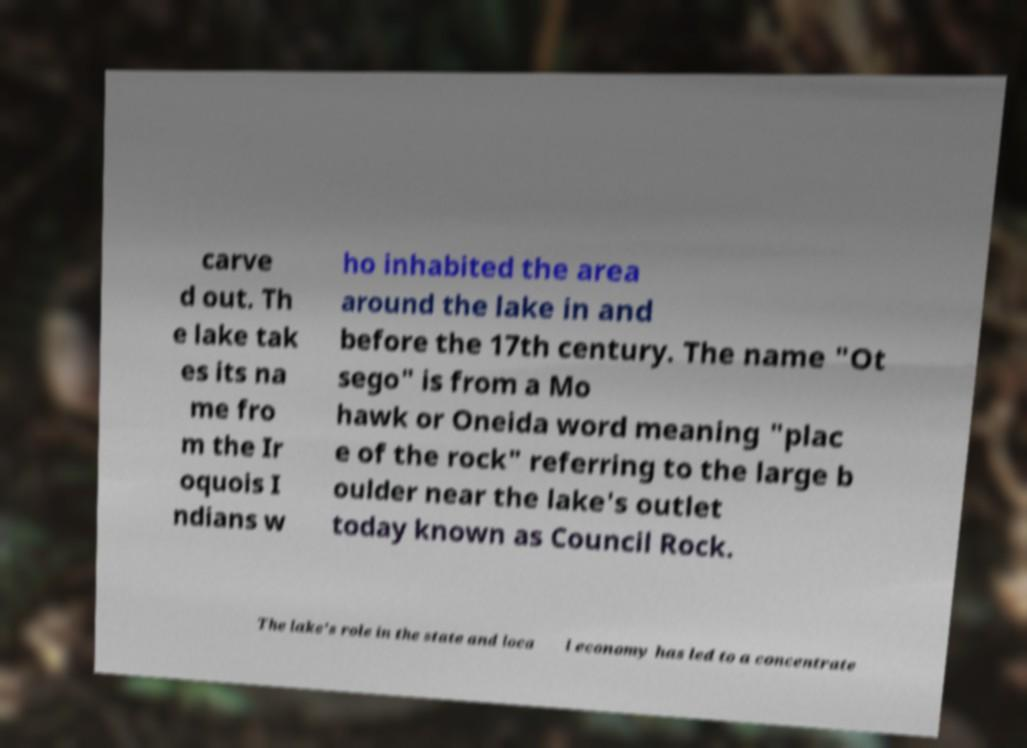There's text embedded in this image that I need extracted. Can you transcribe it verbatim? carve d out. Th e lake tak es its na me fro m the Ir oquois I ndians w ho inhabited the area around the lake in and before the 17th century. The name "Ot sego" is from a Mo hawk or Oneida word meaning "plac e of the rock" referring to the large b oulder near the lake's outlet today known as Council Rock. The lake's role in the state and loca l economy has led to a concentrate 